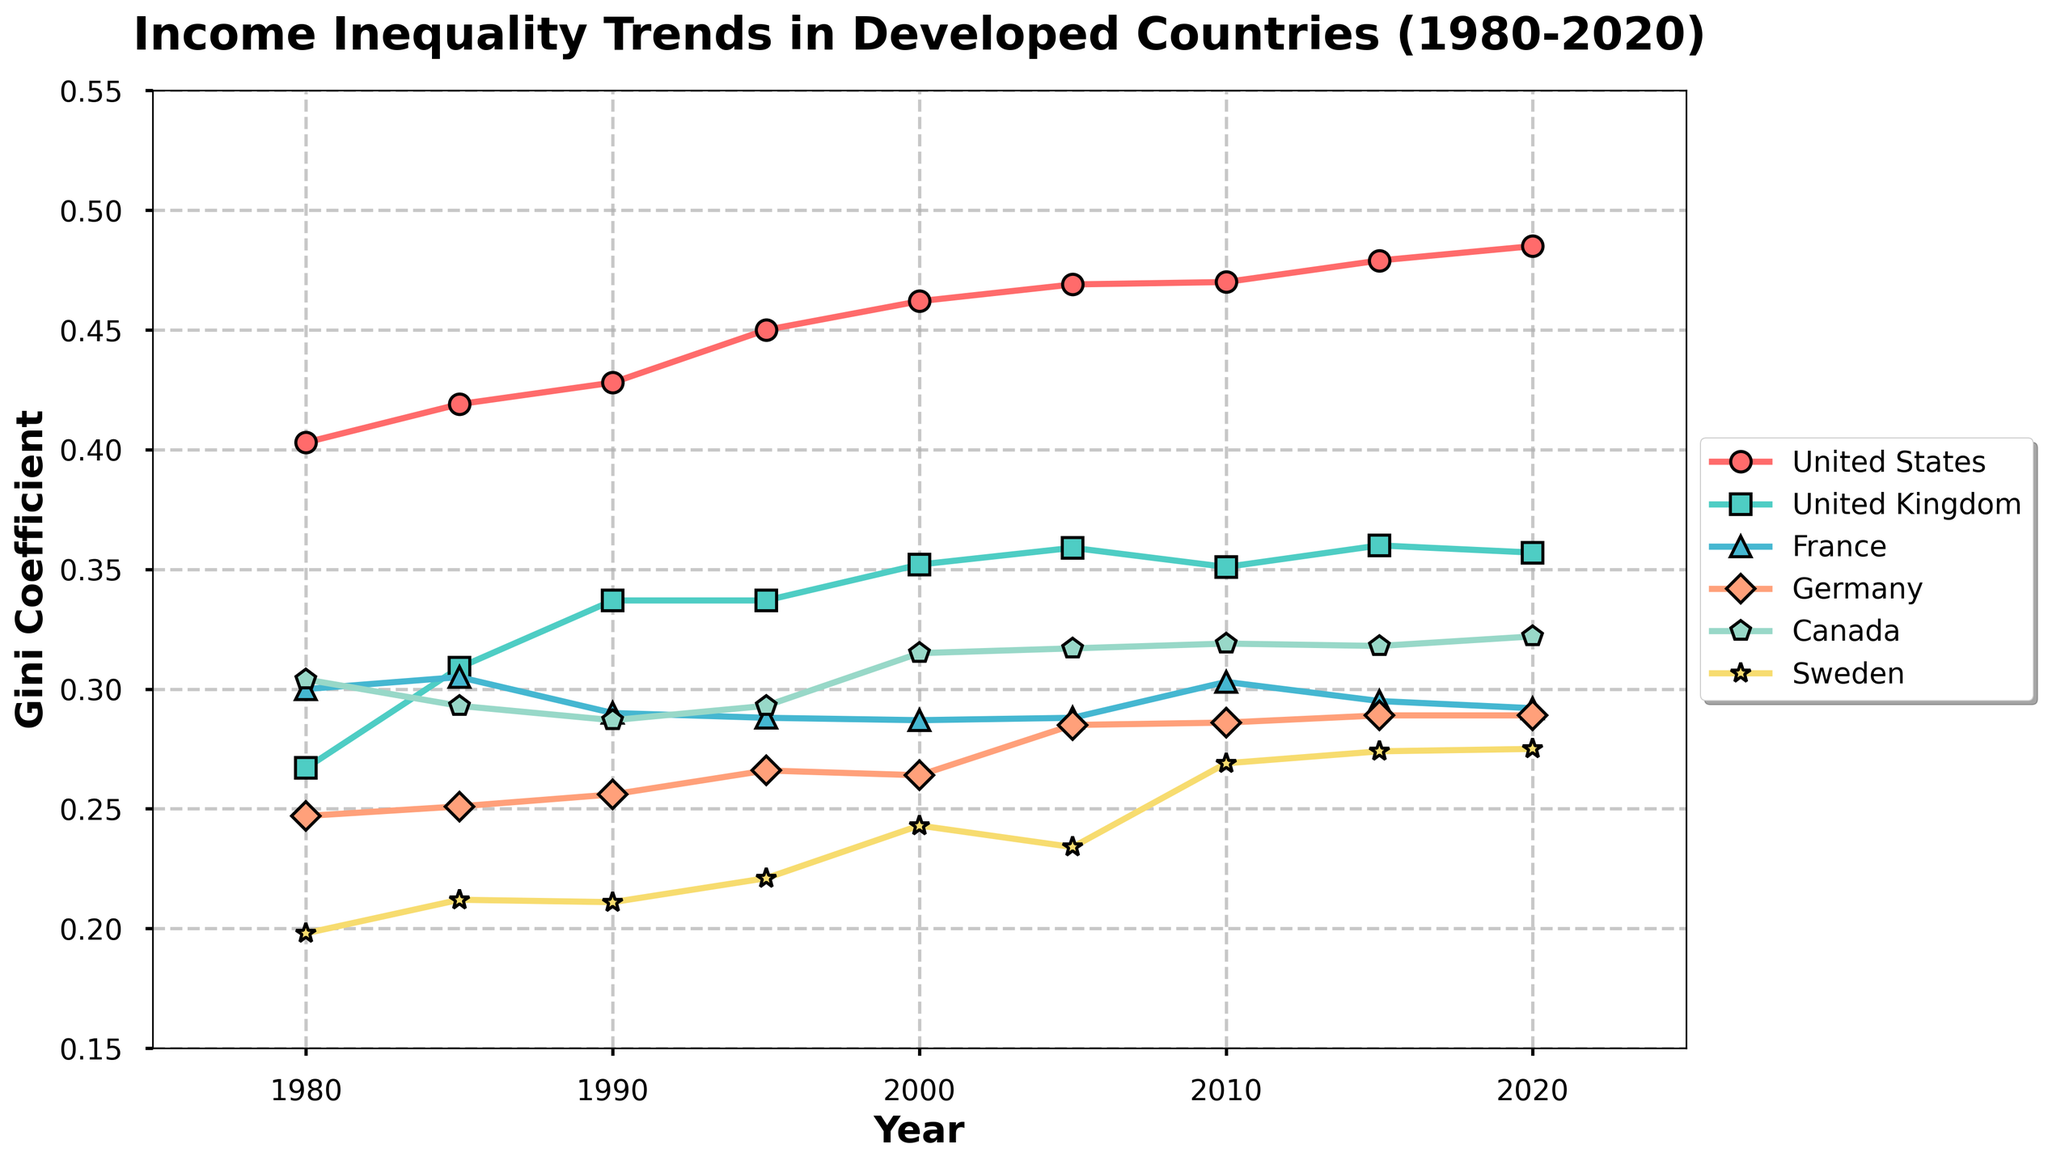What trend can be observed for income inequality in the United States from 1980 to 2020? The Gini coefficient for the United States shows a general upward trend from 1980 (0.403) to 2020 (0.485). This indicates that income inequality in the United States has increased over this period.
Answer: Income inequality increased Which country had the lowest Gini coefficient in 1980, and what was the value? By looking at the starting point of each line on the graph for the year 1980, Sweden had the lowest Gini coefficient at 0.198.
Answer: Sweden, 0.198 How did the income inequality in Germany change between 1980 and 2005? The Gini coefficient for Germany increased from 0.247 in 1980 to 0.285 in 2005.
Answer: It increased Between 1980 and 2020, which country experienced the largest increase in its Gini coefficient? By comparing the differences between the initial and final Gini coefficients for each country, the United States had the largest increase (from 0.403 in 1980 to 0.485 in 2020).
Answer: United States What is the difference in the Gini coefficient between Canada and the United Kingdom in 2020? In 2020, Canada's Gini coefficient was 0.322 and the United Kingdom's was 0.357. The difference is 0.357 - 0.322 = 0.035.
Answer: 0.035 Which country had a decrease in its Gini coefficient between any two consecutive time points, and in what years? By examining the lines carefully, France had a decrease from 0.305 in 1985 to 0.290 in 1990.
Answer: France, 1985-1990 What was the average Gini coefficient for Sweden across the given years? The Gini coefficients for Sweden are: 0.198, 0.212, 0.211, 0.221, 0.243, 0.234, 0.269, 0.274, and 0.275. Summing these values gives 2.137, and dividing by 9 gives approximately 0.2374.
Answer: 0.2374 Compare the trends of income inequality in the United Kingdom and Germany from 1980 to 2020. The Gini coefficient for the United Kingdom increased from 0.267 in 1980 to 0.357 in 2020. For Germany, it increased from 0.247 in 1980 to 0.289 in 2020. Both countries show an upward trend, but the increase in the United Kingdom is more pronounced.
Answer: Both increased, UK more sharply How did the Gini coefficient in France change between 2000 and 2020? For France, the Gini coefficient changed from 0.287 in 2000 to 0.292 in 2020.
Answer: It slightly increased 